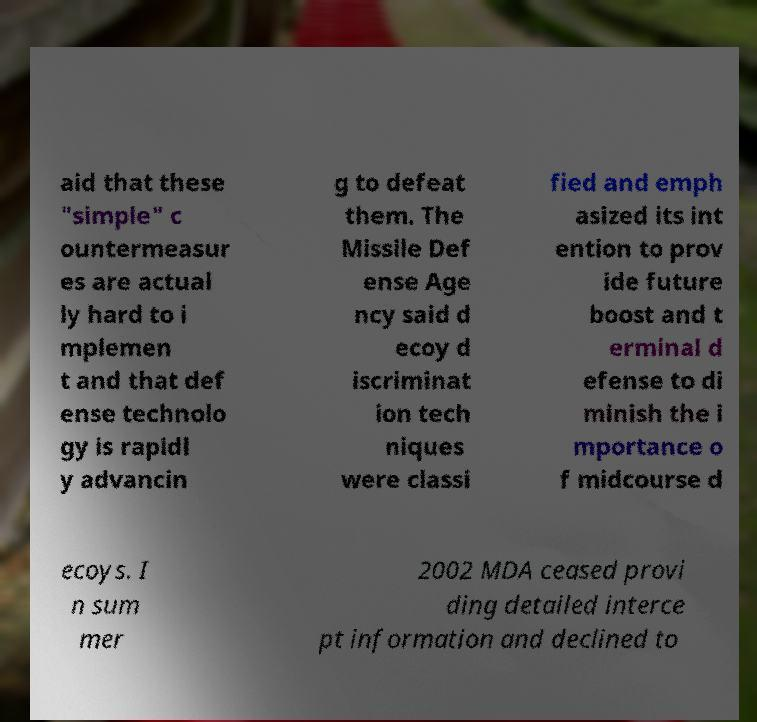Can you read and provide the text displayed in the image?This photo seems to have some interesting text. Can you extract and type it out for me? aid that these "simple" c ountermeasur es are actual ly hard to i mplemen t and that def ense technolo gy is rapidl y advancin g to defeat them. The Missile Def ense Age ncy said d ecoy d iscriminat ion tech niques were classi fied and emph asized its int ention to prov ide future boost and t erminal d efense to di minish the i mportance o f midcourse d ecoys. I n sum mer 2002 MDA ceased provi ding detailed interce pt information and declined to 